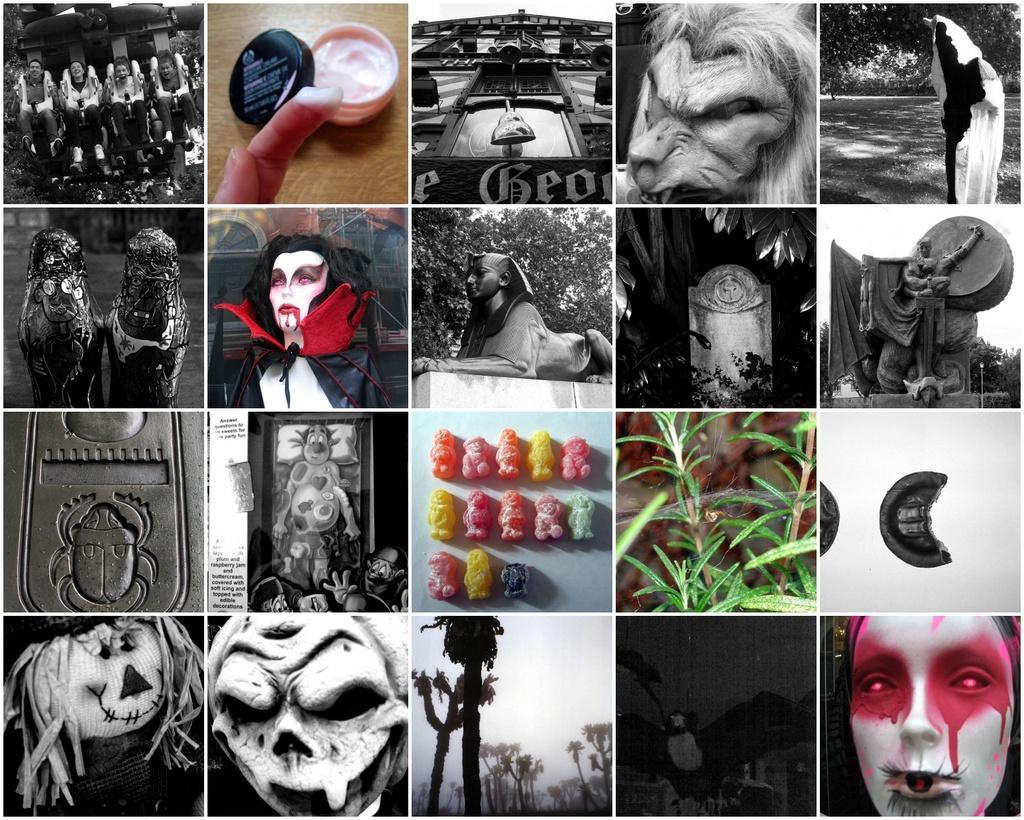Could you give a brief overview of what you see in this image? This is a college of few images. In those images there are few people with a ride, cream with ginger, monsters, buildings, sculptures, statues, toys, frames, trees, bay, leaves, different color toys on the white surface and there is an object with bug symbol on it. 